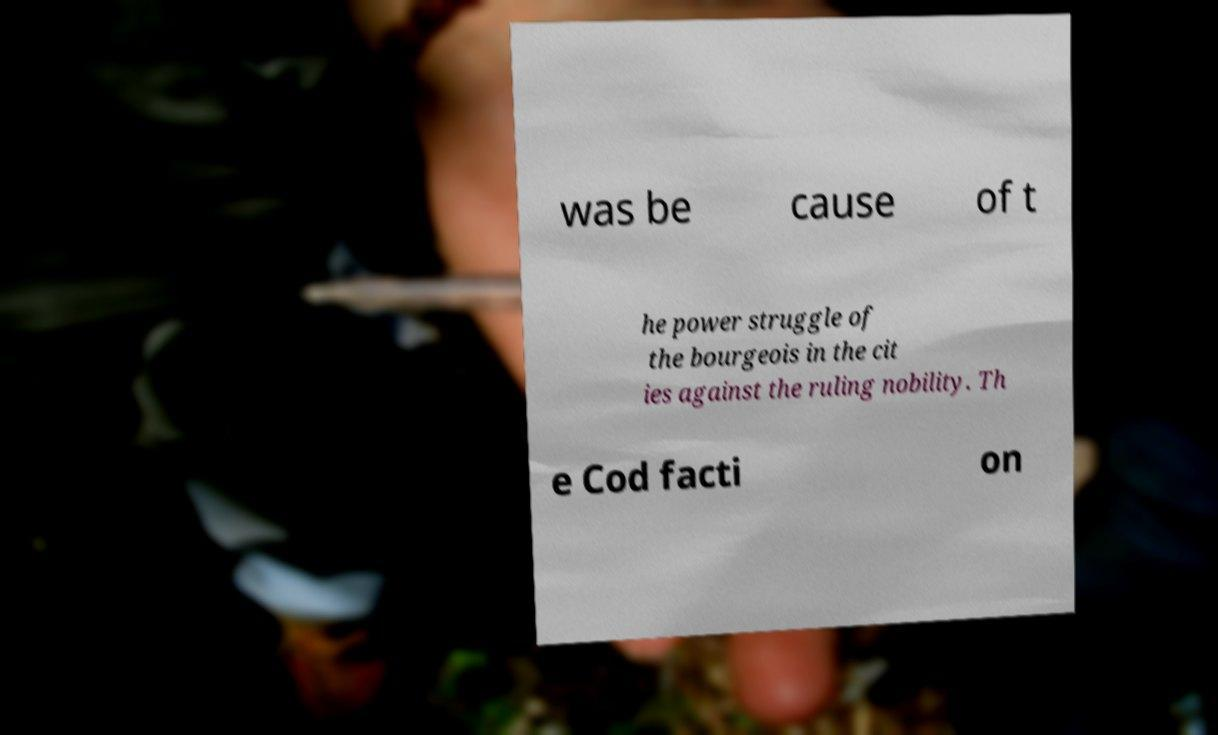I need the written content from this picture converted into text. Can you do that? was be cause of t he power struggle of the bourgeois in the cit ies against the ruling nobility. Th e Cod facti on 